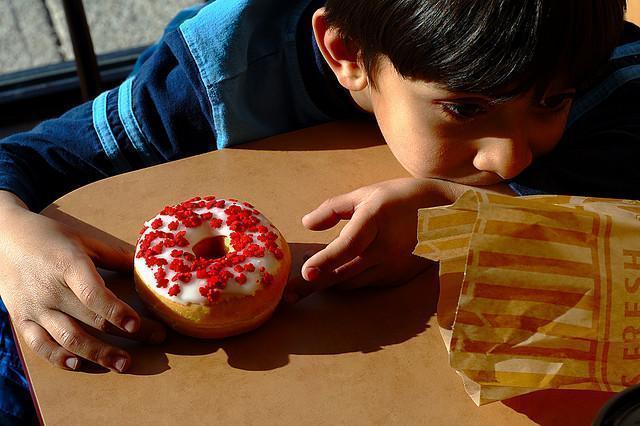When did the restaurant make this donut?
Indicate the correct response by choosing from the four available options to answer the question.
Options: Same day, month before, week before, day before. Same day. 